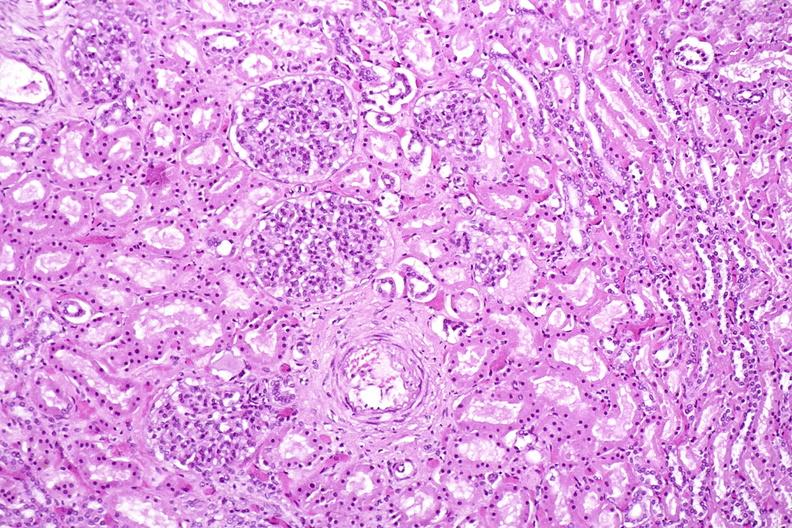does sickle cell disease show kidney, normal histology?
Answer the question using a single word or phrase. No 